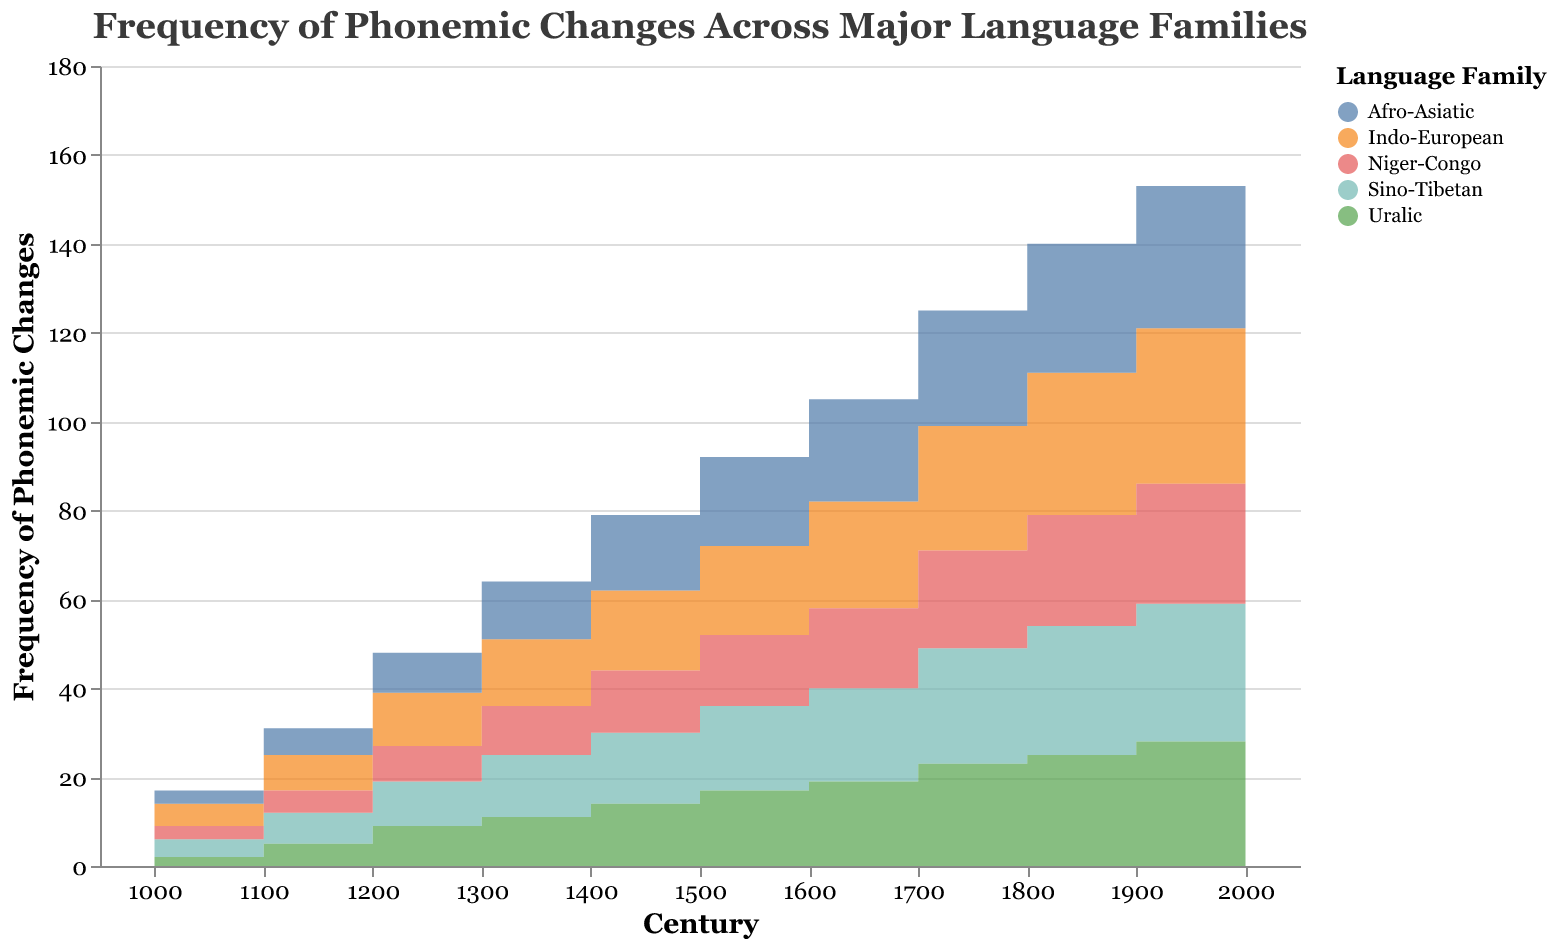What is the title of the chart? The title can be found at the top of the chart.
Answer: Frequency of Phonemic Changes Across Major Language Families Which language family showed the greatest phonemic changes in the year 2000? Look at the points representing the phonemic changes for each language family at the year 2000 and identify the highest one.
Answer: Indo-European How many phonemic changes occurred in the Niger-Congo language family in the 17th century? Locate the data point for Niger-Congo at the century mark of 1700 on the x-axis and read the corresponding value on the y-axis.
Answer: 22 Compare the frequency of phonemic changes in the 1500s between Afro-Asiatic and Indo-European language families. Which had more changes? Identify the values for phonemic changes in the 1500s for both language families and compare them. Afro-Asiatic has 20 while Indo-European has 20. Both had an equal number of changes.
Answer: Both had an equal number of changes By how much did the phonemic changes in the Indo-European language family increase from the 1000s to the 2000s? Subtract the number of phonemic changes in the 1000s from the 2000s for Indo-European. 38 - 5 = 33.
Answer: 33 Which language family had the least phonemic changes in the 1000s? Identify the value of phonemic changes for each language family in the 1000s and find the smallest one.
Answer: Uralic Estimate the average rate of change in phonemic changes per century for the Sino-Tibetan language family from 1000 to 2000. Calculate the total change from 4 in 1000 to 35 in 2000 (35 - 4 = 31). Then divide the total change by the number of centuries (10). So, 31 / 10 = 3.1 changes per century.
Answer: 3.1 changes per century Comparing the phonemic changes across language families in the 1300s, which two language families had the same frequency of changes? Look at the values for each language family in the 1300s and find the ones that are equal. Afro-Asiatic and Sino-Tibetan both had 13 changes.
Answer: Afro-Asiatic and Sino-Tibetan In which century did the Uralic language family experience the highest rate of increase in phonemic changes? Identify the century with the largest difference in phonemic changes from one century to the next. The highest change is between 1600 (19) and 1700 (23).
Answer: Between 1600 and 1700 